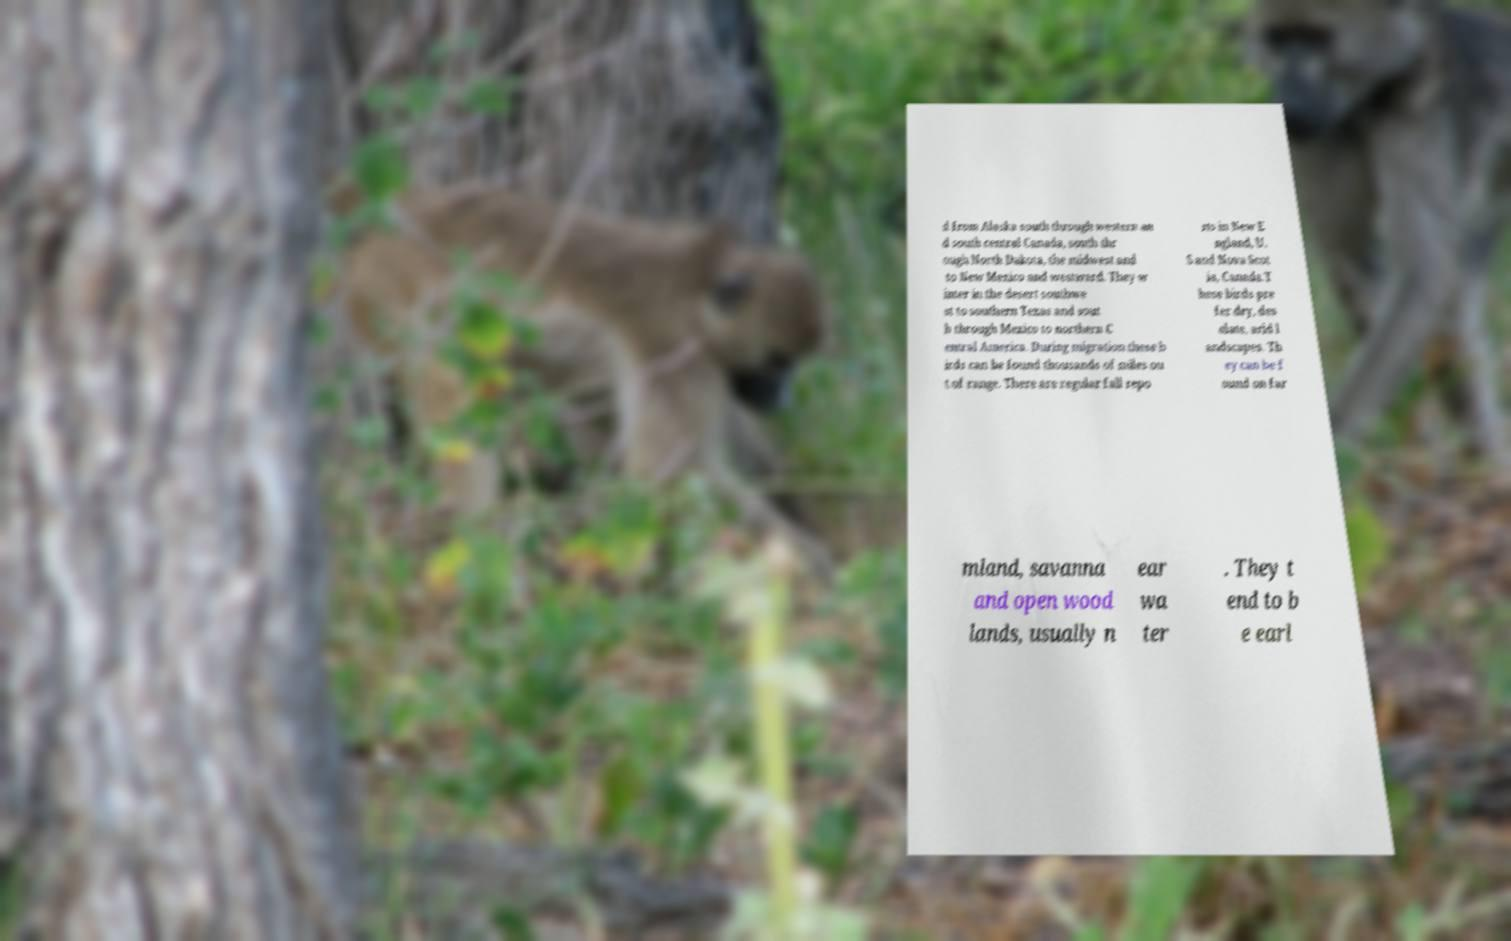What messages or text are displayed in this image? I need them in a readable, typed format. d from Alaska south through western an d south central Canada, south thr ough North Dakota, the midwest and to New Mexico and westward. They w inter in the desert southwe st to southern Texas and sout h through Mexico to northern C entral America. During migration these b irds can be found thousands of miles ou t of range. There are regular fall repo rts in New E ngland, U. S and Nova Scot ia, Canada.T hese birds pre fer dry, des olate, arid l andscapes. Th ey can be f ound on far mland, savanna and open wood lands, usually n ear wa ter . They t end to b e earl 